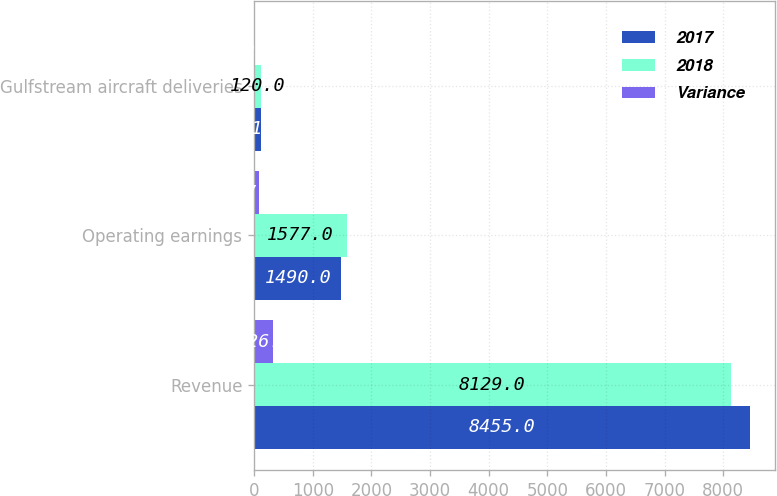<chart> <loc_0><loc_0><loc_500><loc_500><stacked_bar_chart><ecel><fcel>Revenue<fcel>Operating earnings<fcel>Gulfstream aircraft deliveries<nl><fcel>2017<fcel>8455<fcel>1490<fcel>121<nl><fcel>2018<fcel>8129<fcel>1577<fcel>120<nl><fcel>Variance<fcel>326<fcel>87<fcel>1<nl></chart> 